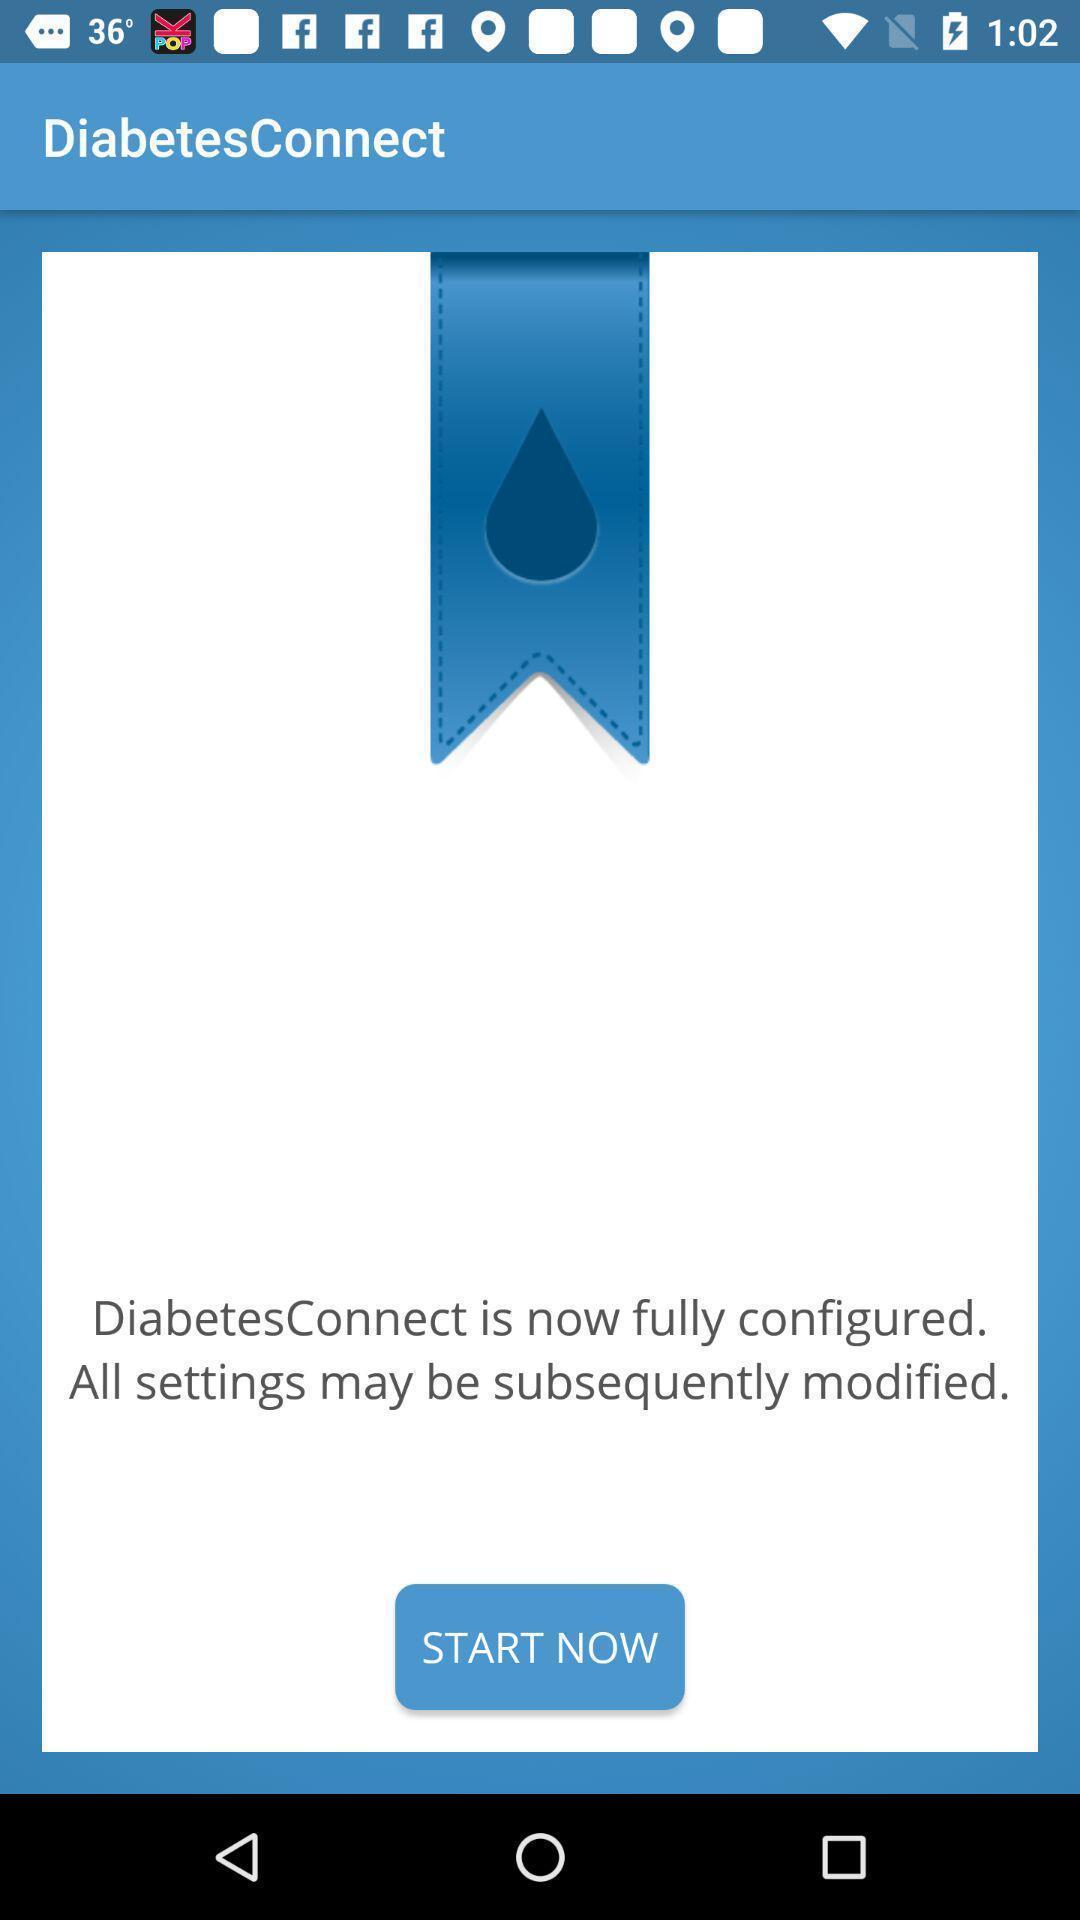What is the overall content of this screenshot? Welcome page of a medical application. 